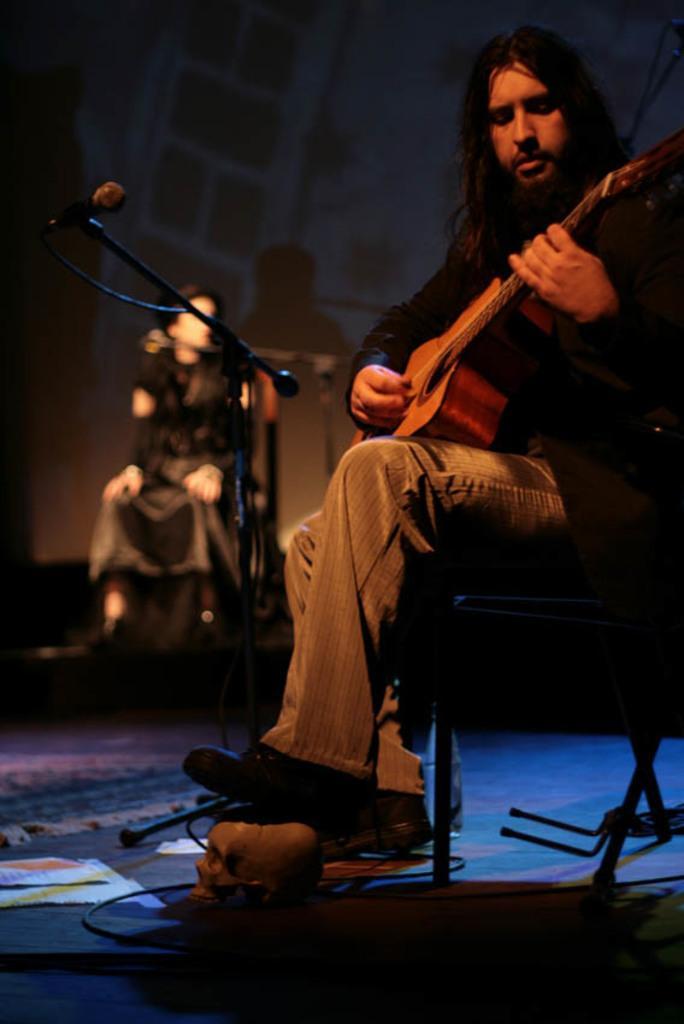Could you give a brief overview of what you see in this image? A person is sitting and playing the guitar. 